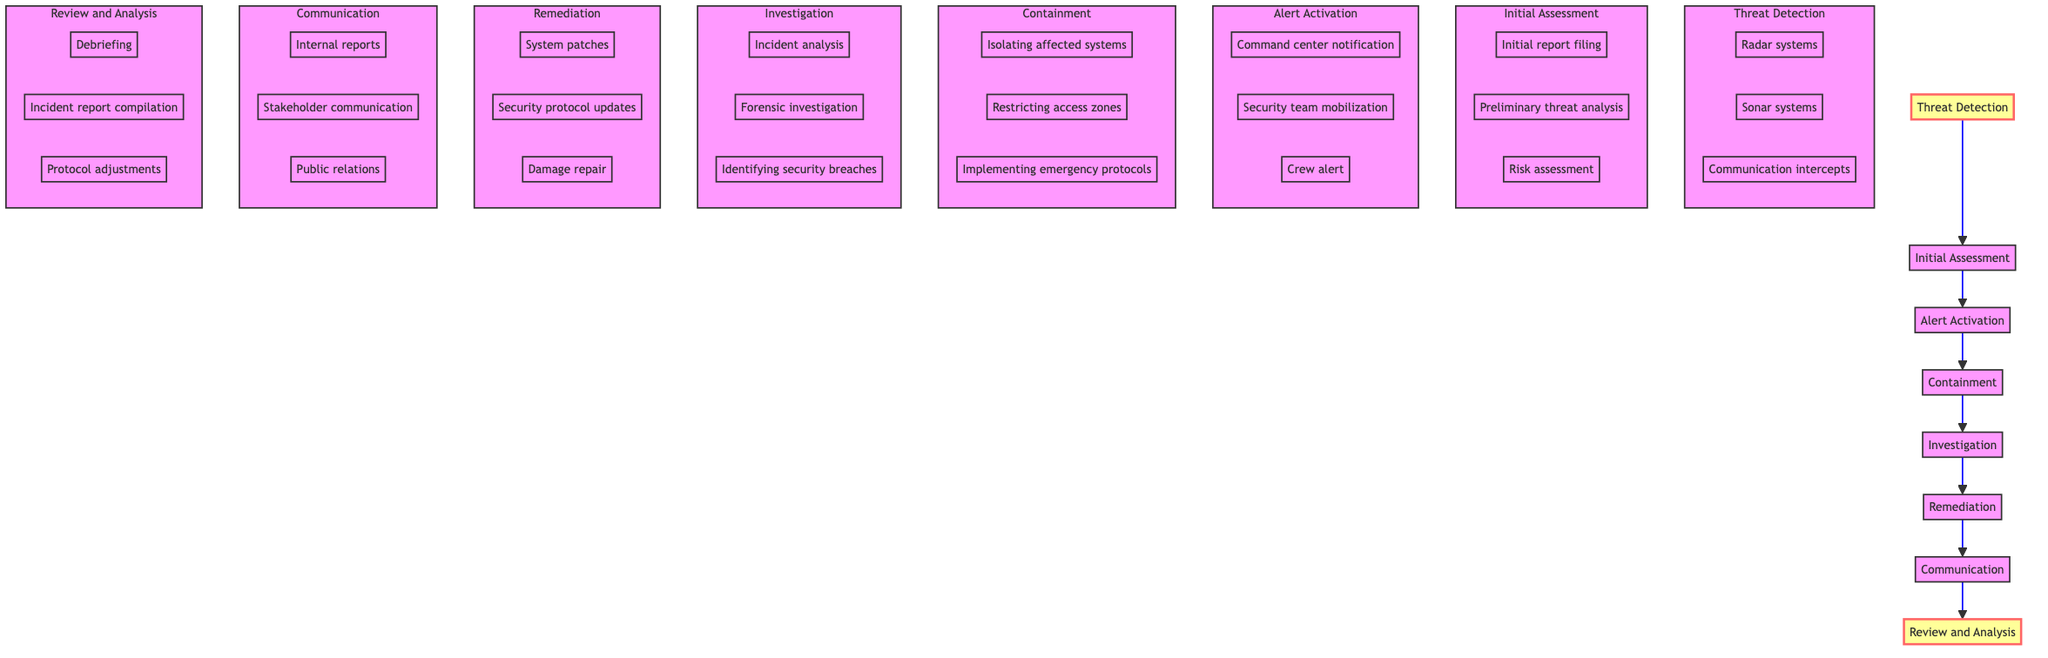What is the first step in the incident response protocol? The first step in the diagram is "Threat Detection," which indicates the initial recognition of a potential security incident.
Answer: Threat Detection How many elements are in the incident response flow? The diagram contains eight distinct elements or nodes detailing the incident response protocol from detection to review.
Answer: Eight Which step comes after "Initial Assessment"? Referring to the flow, "Alert Activation" is listed directly after "Initial Assessment," indicating the next action to notify relevant teams.
Answer: Alert Activation What is the last step of the protocol? The final step in the incident response flow is "Review and Analysis," where a post-incident review is conducted to improve future responses.
Answer: Review and Analysis Which step involves notifying the command center? The "Alert Activation" step includes notifying the command center as part of the process to activate alerts regarding the incident.
Answer: Alert Activation What type of analysis is performed during the "Investigation"? In the "Investigation" phase, detailed analyses are conducted, such as incident analysis, forensic investigation, and identifying security breaches.
Answer: Detailed analysis How does "Containment" relate to "Investigation"? "Containment" occurs before "Investigation" and focuses on preventing further impact, allowing the investigation to proceed effectively.
Answer: Preventing further impact Which procedure includes "System patches"? "Remediation" entails actions taken to recover from the incident, including applying system patches to restore normal operations.
Answer: Remediation What action is taken after "Communication"? Following "Communication," the next step is "Review and Analysis," which is about reviewing the incident to enhance future responses.
Answer: Review and Analysis 